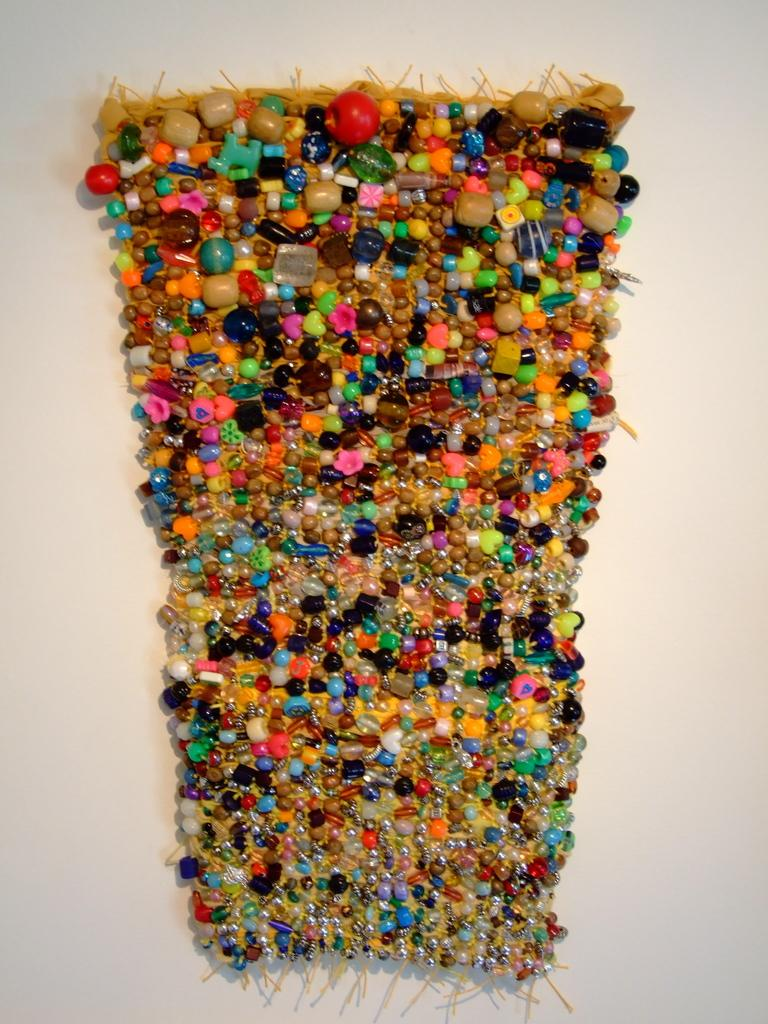What is the main subject of the image? There is a colorful object in the image. Can you describe the colorful object in the image? Unfortunately, the provided facts do not give enough information to describe the colorful object. What is the color of the surface on which the object is placed? The object is on a white surface. Where is the jail located in the image? There is no jail present in the image. What type of throne is depicted in the image? There is no throne present in the image. Can you see a giraffe in the image? There is no giraffe present in the image. 